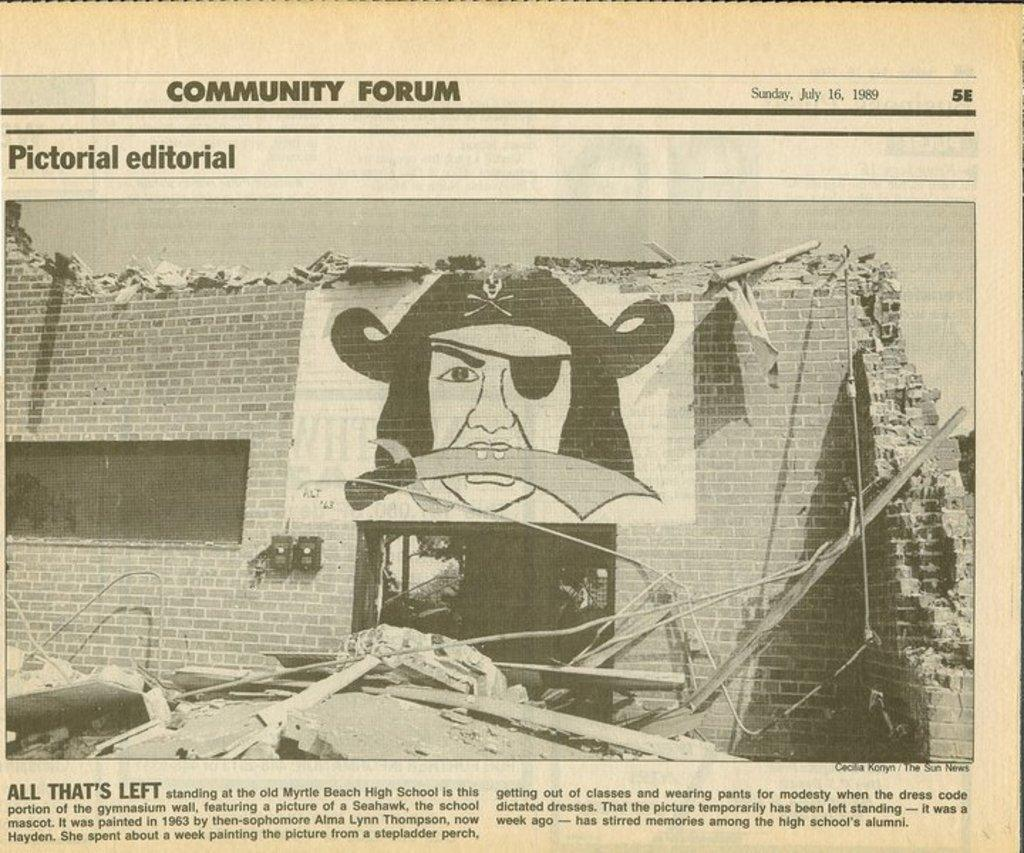What is the main object visible in the image? There is a newspaper in the image. What is depicted on the newspaper? The newspaper contains a wall. What can be seen in the newspaper besides the wall? There is text visible in the newspaper. Can you see any steam coming from the wall in the image? There is no steam visible in the image; it features a newspaper with a wall depicted on it. How many visitors are present in the image? There is no reference to any visitors in the image; it only shows a newspaper with a wall depicted on it. 